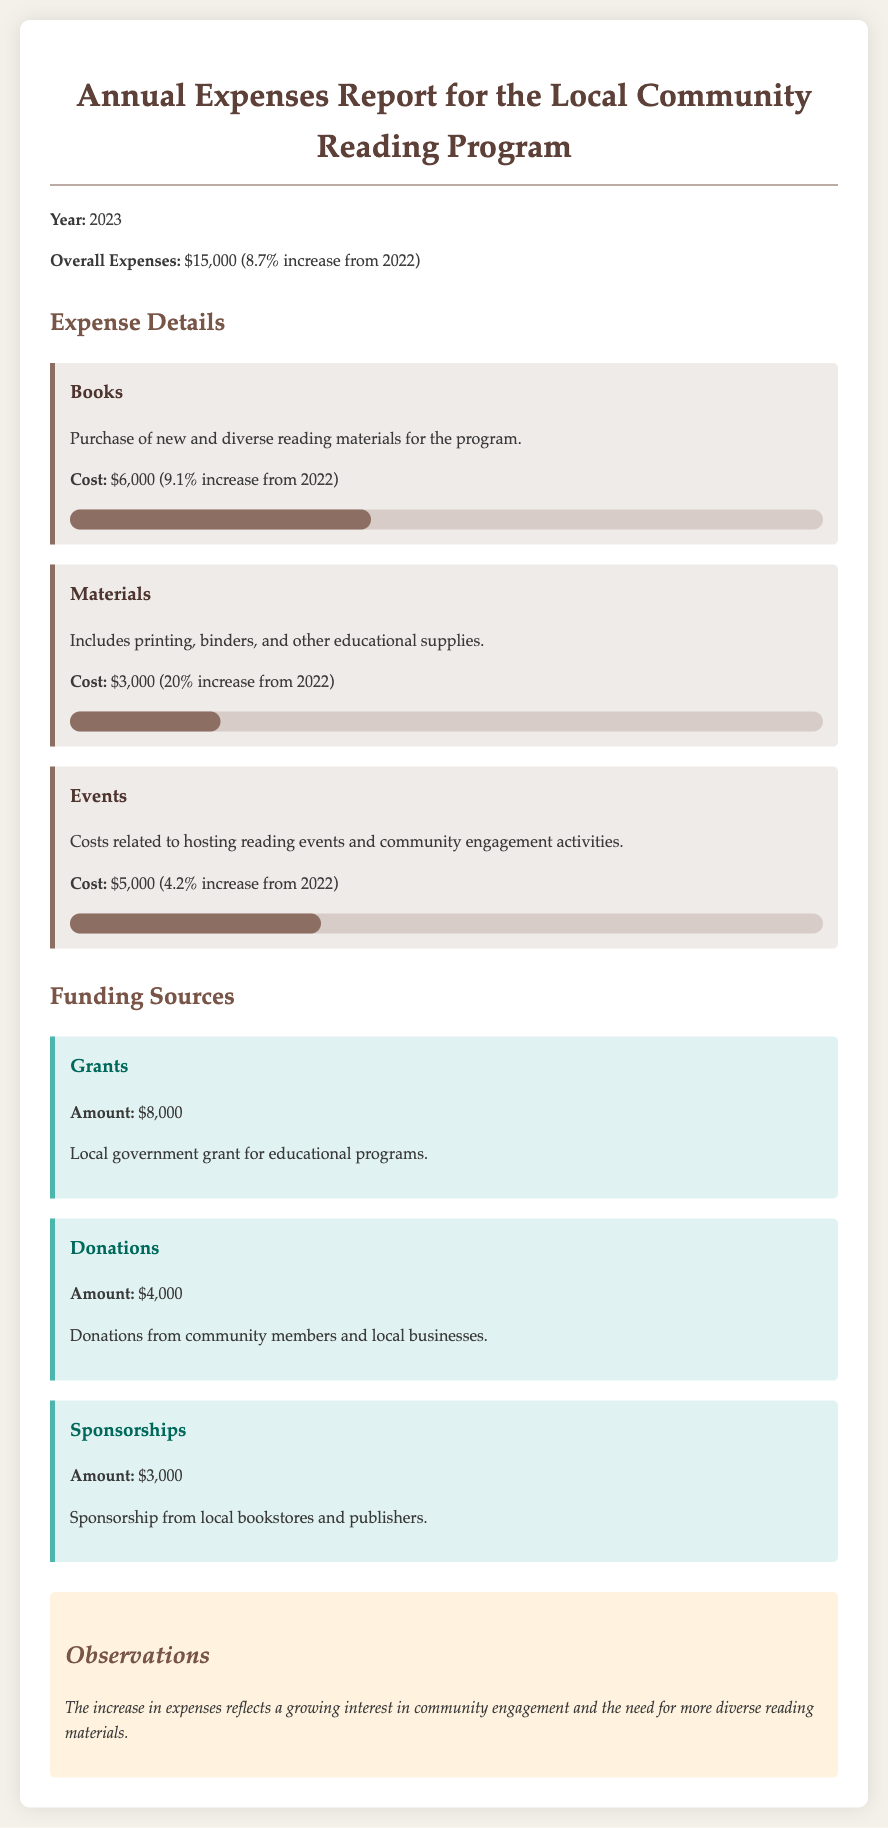What were the overall expenses for 2023? The overall expenses are explicitly stated in the report as $15,000.
Answer: $15,000 What was the cost of books for the program? The report clearly states the cost of books as $6,000.
Answer: $6,000 How much has the cost for materials increased from 2022? The increase in the cost of materials is given as 20% from the previous year.
Answer: 20% What was the funding amount from grants? The amount received from grants is specified as $8,000 in the report.
Answer: $8,000 Which category had the highest expense? The category with the highest expense is identified as books at $6,000.
Answer: Books What percentage increase was noted for overall expenses from the previous year? The overall expenses reported an increase of 8.7% from 2022.
Answer: 8.7% How much funding comes from sponsorships? The total funding from sponsorships is stated to be $3,000.
Answer: $3,000 What was the cost allocated for events? The report specifies the cost allocated for events as $5,000.
Answer: $5,000 What observation was made regarding the increase in expenses? The observation states that the increase reflects growing interest and need for more diverse materials.
Answer: Growing interest in community engagement 